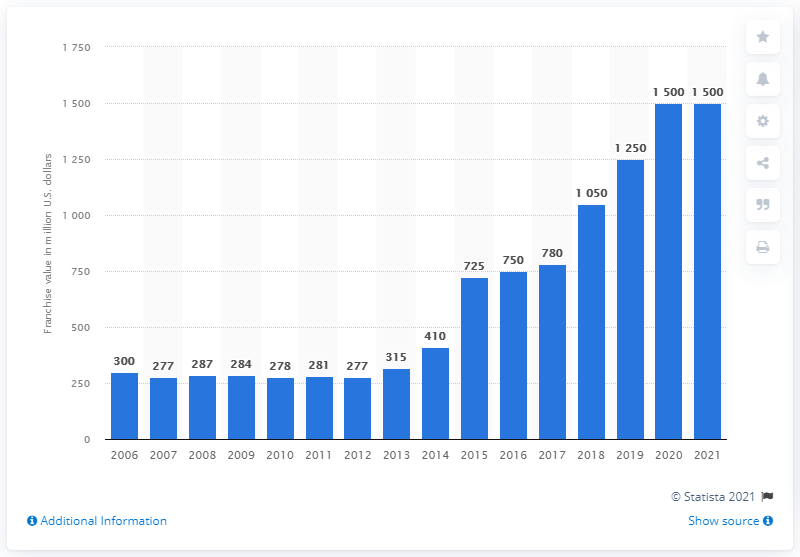Point out several critical features in this image. The estimated value of the Charlotte Hornets in 2021 was approximately 1500. 